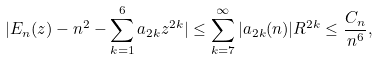Convert formula to latex. <formula><loc_0><loc_0><loc_500><loc_500>| E _ { n } ( z ) - n ^ { 2 } - \sum _ { k = 1 } ^ { 6 } a _ { 2 k } z ^ { 2 k } | \leq \sum _ { k = 7 } ^ { \infty } | a _ { 2 k } ( n ) | R ^ { 2 k } \leq \frac { C _ { n } } { n ^ { 6 } } ,</formula> 